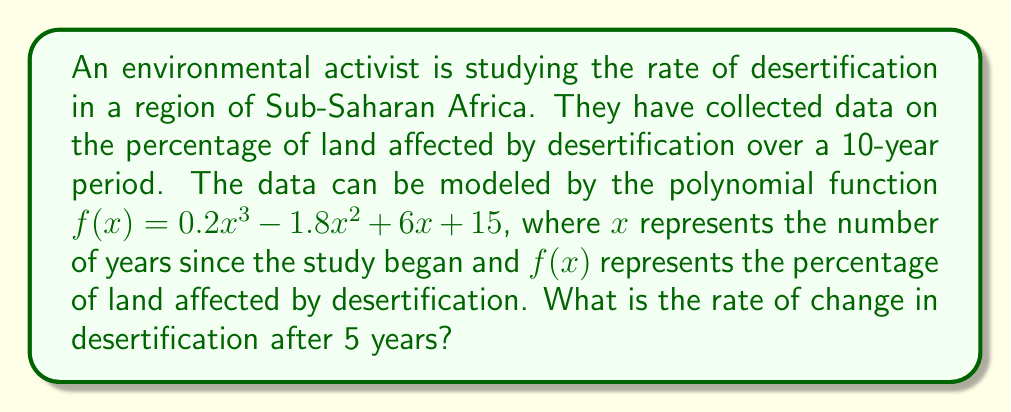Provide a solution to this math problem. To find the rate of change in desertification after 5 years, we need to follow these steps:

1. The rate of change is given by the derivative of the function $f(x)$.

2. Let's find the derivative $f'(x)$:
   $$f'(x) = \frac{d}{dx}(0.2x^3 - 1.8x^2 + 6x + 15)$$
   $$f'(x) = 0.6x^2 - 3.6x + 6$$

3. Now that we have the derivative, we need to evaluate it at $x = 5$:
   $$f'(5) = 0.6(5^2) - 3.6(5) + 6$$
   $$f'(5) = 0.6(25) - 18 + 6$$
   $$f'(5) = 15 - 18 + 6$$
   $$f'(5) = 3$$

4. The result, 3, represents the rate of change in percentage points per year after 5 years.
Answer: 3 percentage points per year 